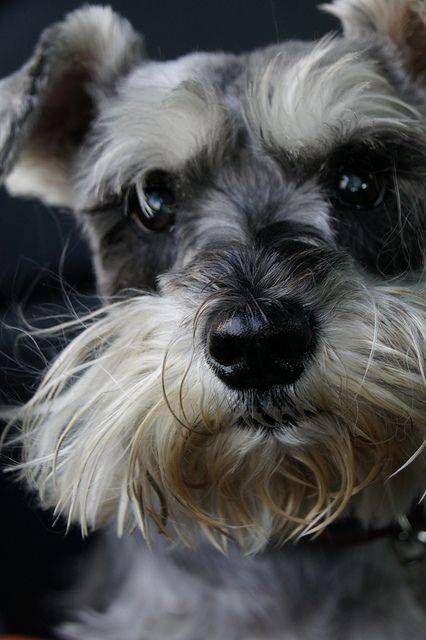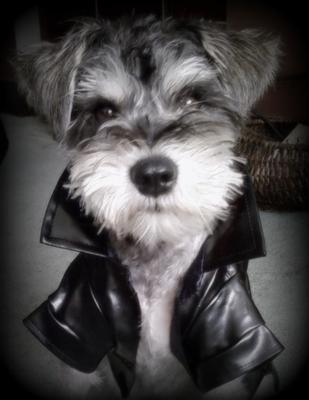The first image is the image on the left, the second image is the image on the right. Analyze the images presented: Is the assertion "Each image shows a single schnauzer that is not in costume, and at least one image features a dog with its tongue sticking out." valid? Answer yes or no. No. The first image is the image on the left, the second image is the image on the right. Considering the images on both sides, is "The dog in at least one of the images has its tongue hanging out." valid? Answer yes or no. No. 